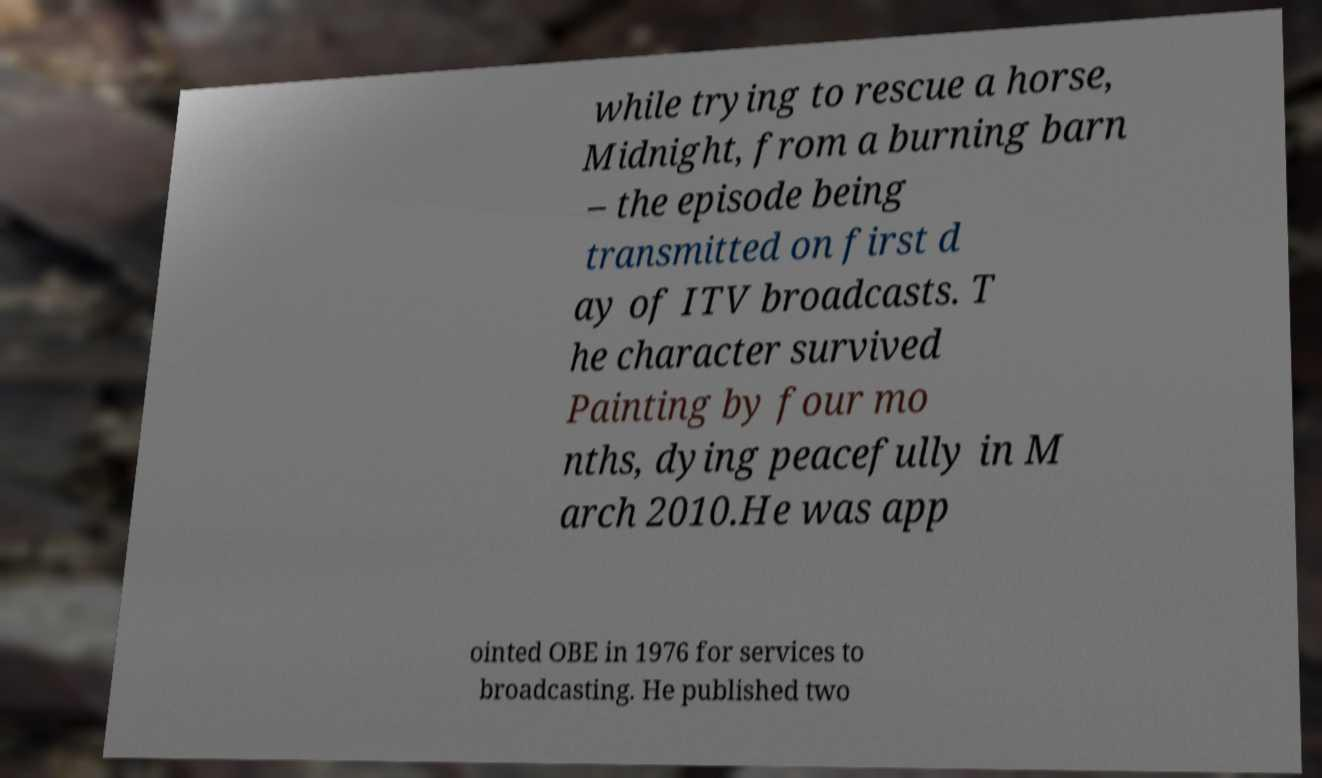Can you accurately transcribe the text from the provided image for me? while trying to rescue a horse, Midnight, from a burning barn – the episode being transmitted on first d ay of ITV broadcasts. T he character survived Painting by four mo nths, dying peacefully in M arch 2010.He was app ointed OBE in 1976 for services to broadcasting. He published two 